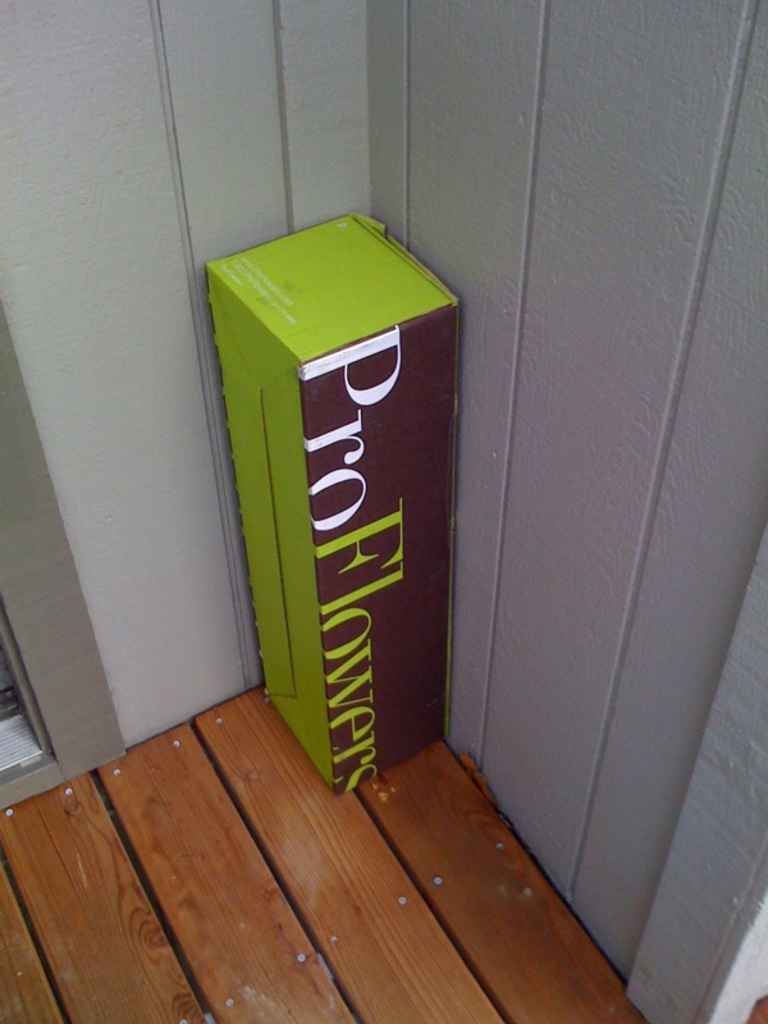Can you describe the main features of this image for me? The image features an unopened delivery box from ProFlowers, which is placed vertically against a gray wall, resting on a wooden deck. The box is striking with its bright lime green and deep purple color scheme, prominently displaying the 'ProFlowers' logo. These colors make the box stand out in the otherwise muted surroundings, suggesting a special delivery. The box’s slim and tall design hints that it might contain a bouquet of flowers, typically sent for occasions like birthdays or anniversaries. Given that the package is just delivered and left on the deck, it captures a moment of anticipation, where someone is perhaps about to receive or discover a thoughtful gesture from someone. 